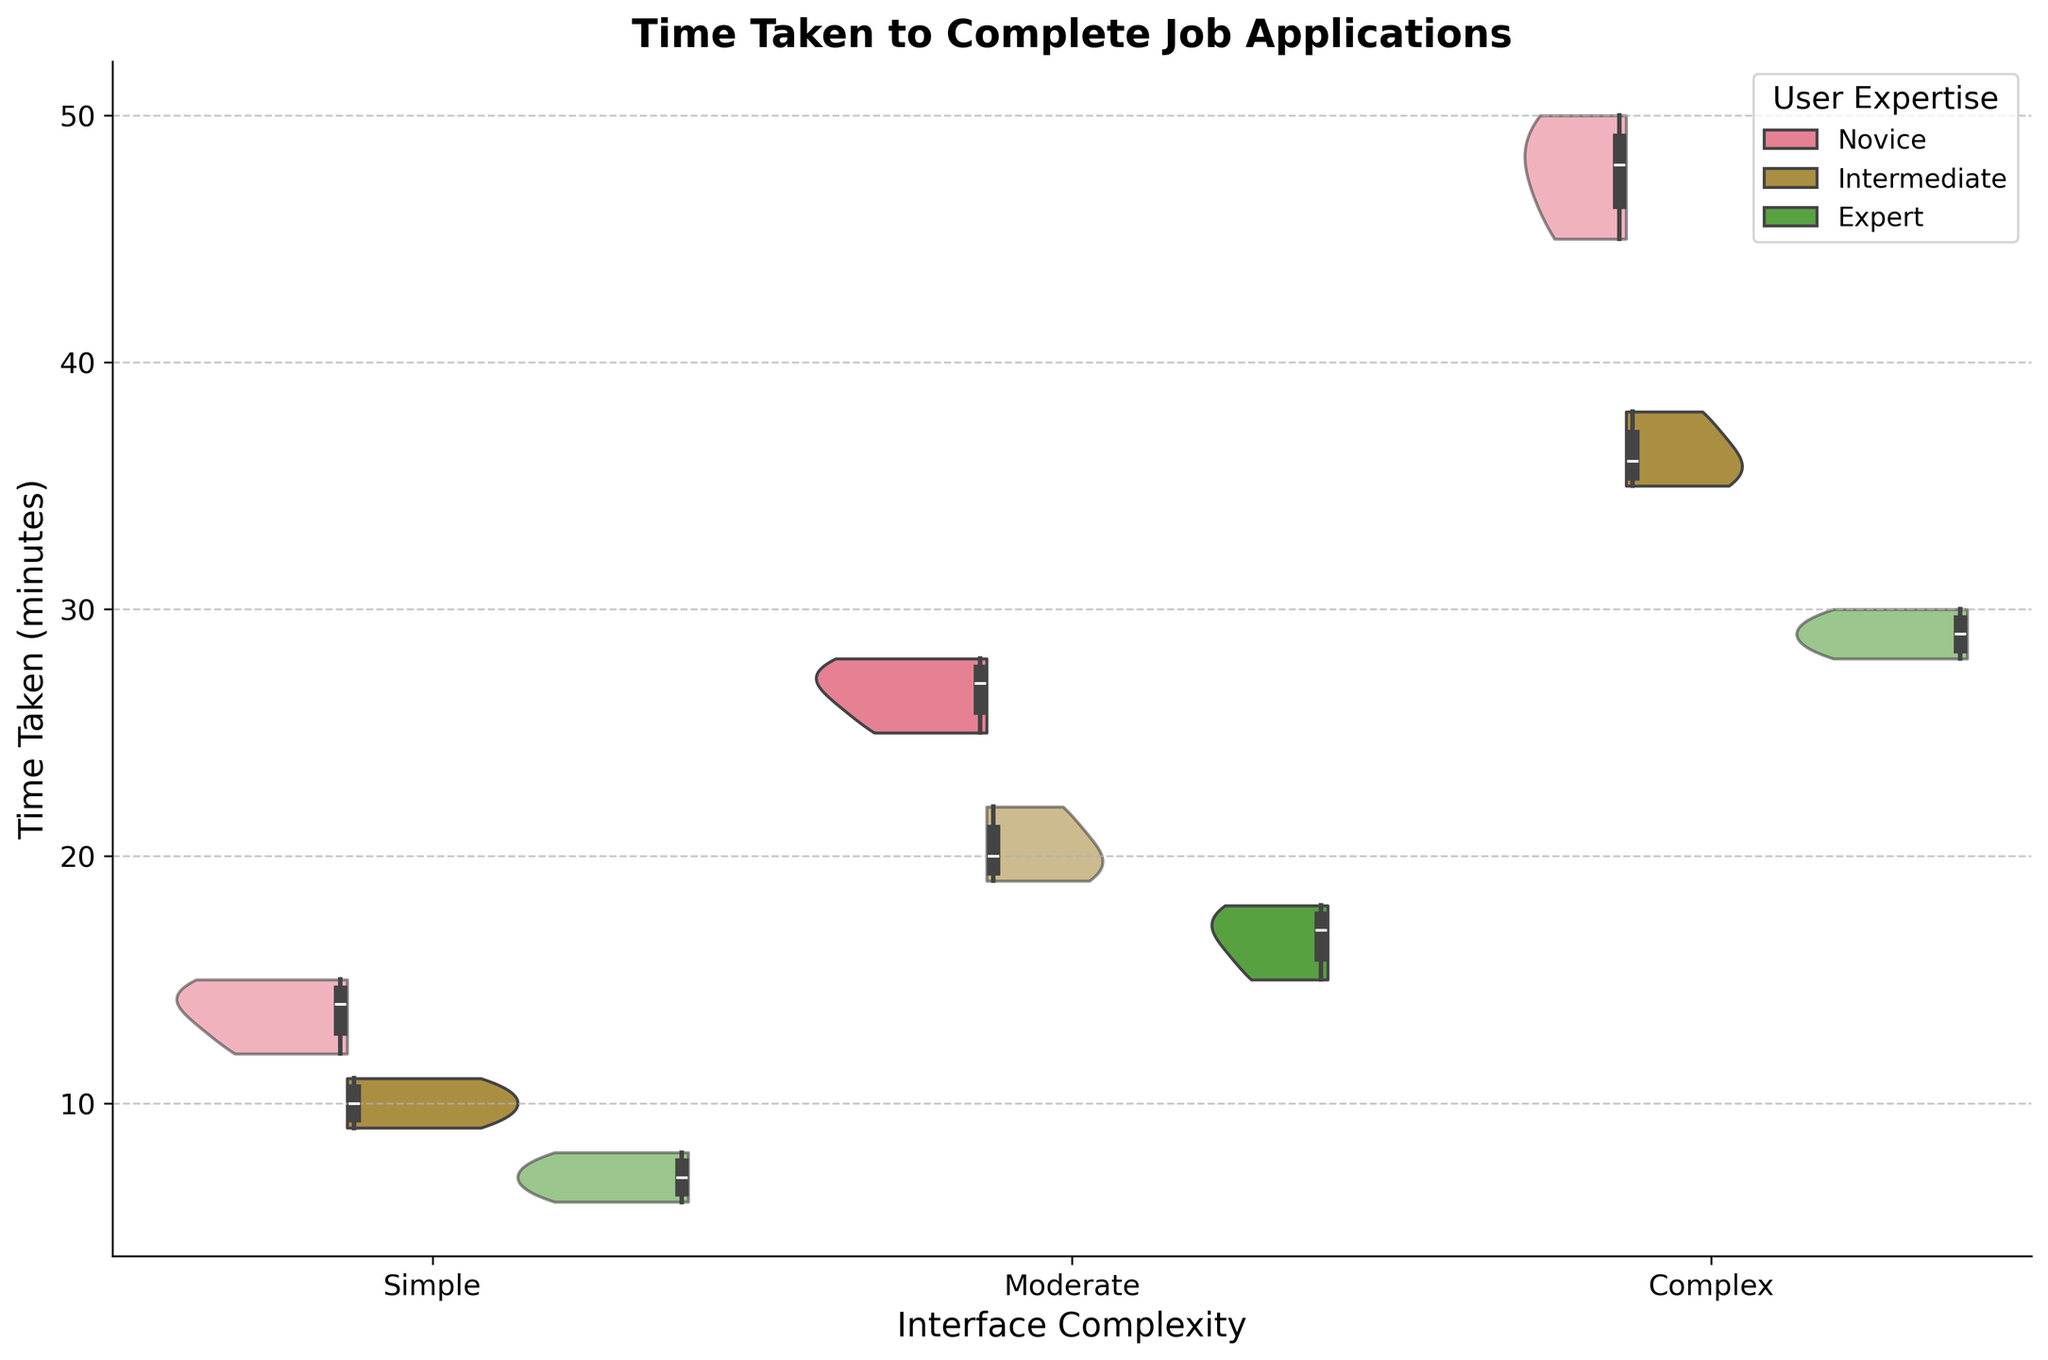What is the title of the figure? The title of the figure is usually positioned at the top and provides a summary of what the figure represents. In this case, it helps users to quickly understand the content of the visualization.
Answer: Time Taken to Complete Job Applications How many levels of interface complexity are shown on the x-axis? To answer this, one needs to look at the labels on the x-axis which represent different levels of interface complexity.
Answer: Three Which category of user expertise has the widest spread in time taken for complex interfaces? By examining the width of the violin plot for each user expertise under the 'Complex' category, we can identify which one has the widest spread. The spread is depicted by the shape of the violin plot.
Answer: Novice What is the median time taken by intermediate users for moderate interfaces? The box plot within the violin plot indicates the median as the line inside the box. Locate the box plot for intermediate users in the 'Moderate' interface category and find the median line.
Answer: 20 minutes Which combination of user expertise and interface complexity shows the lowest time taken? Look for the lowest positions of the box plots within the violin plots across all combinations. Identifying the lowest value will give the answer.
Answer: Expert with Simple interface Comparing novice and expert users, who takes longer on average to complete job applications for moderate interfaces? By comparing the central tendency (median) and overall distribution (mean if inferrable) of novice and expert's time taken for the 'Moderate' category, we can determine who, on average, takes longer.
Answer: Novice users What is the range of times taken by novice users for complex interfaces? The range can be found by subtracting the minimum value from the maximum value in the box plot for novice users under the 'Complex' interface category.
Answer: 45 minutes to 50 minutes How does the time taken differ between intermediate and expert users for simple interfaces? Examine the box plots for intermediate and expert users within the 'Simple' interface category to compare their median values and overall distributions.
Answer: Intermediate users take more time than expert users For moderate interfaces, how does the interquartile range (IQR) of novice users compare to that of expert users? The IQR is represented by the length of the box in the box plot. Compare the length of the boxes for novice and expert users within the 'Moderate' interface category.
Answer: Novice users have a wider IQR Is there more variability in time taken by users in the simple or complex interface category? Variability can be assessed by the width and spread of the violin plots for each interface category. Compare the overall spread of the violin plots under 'Simple' and 'Complex' categories.
Answer: Complex interface 